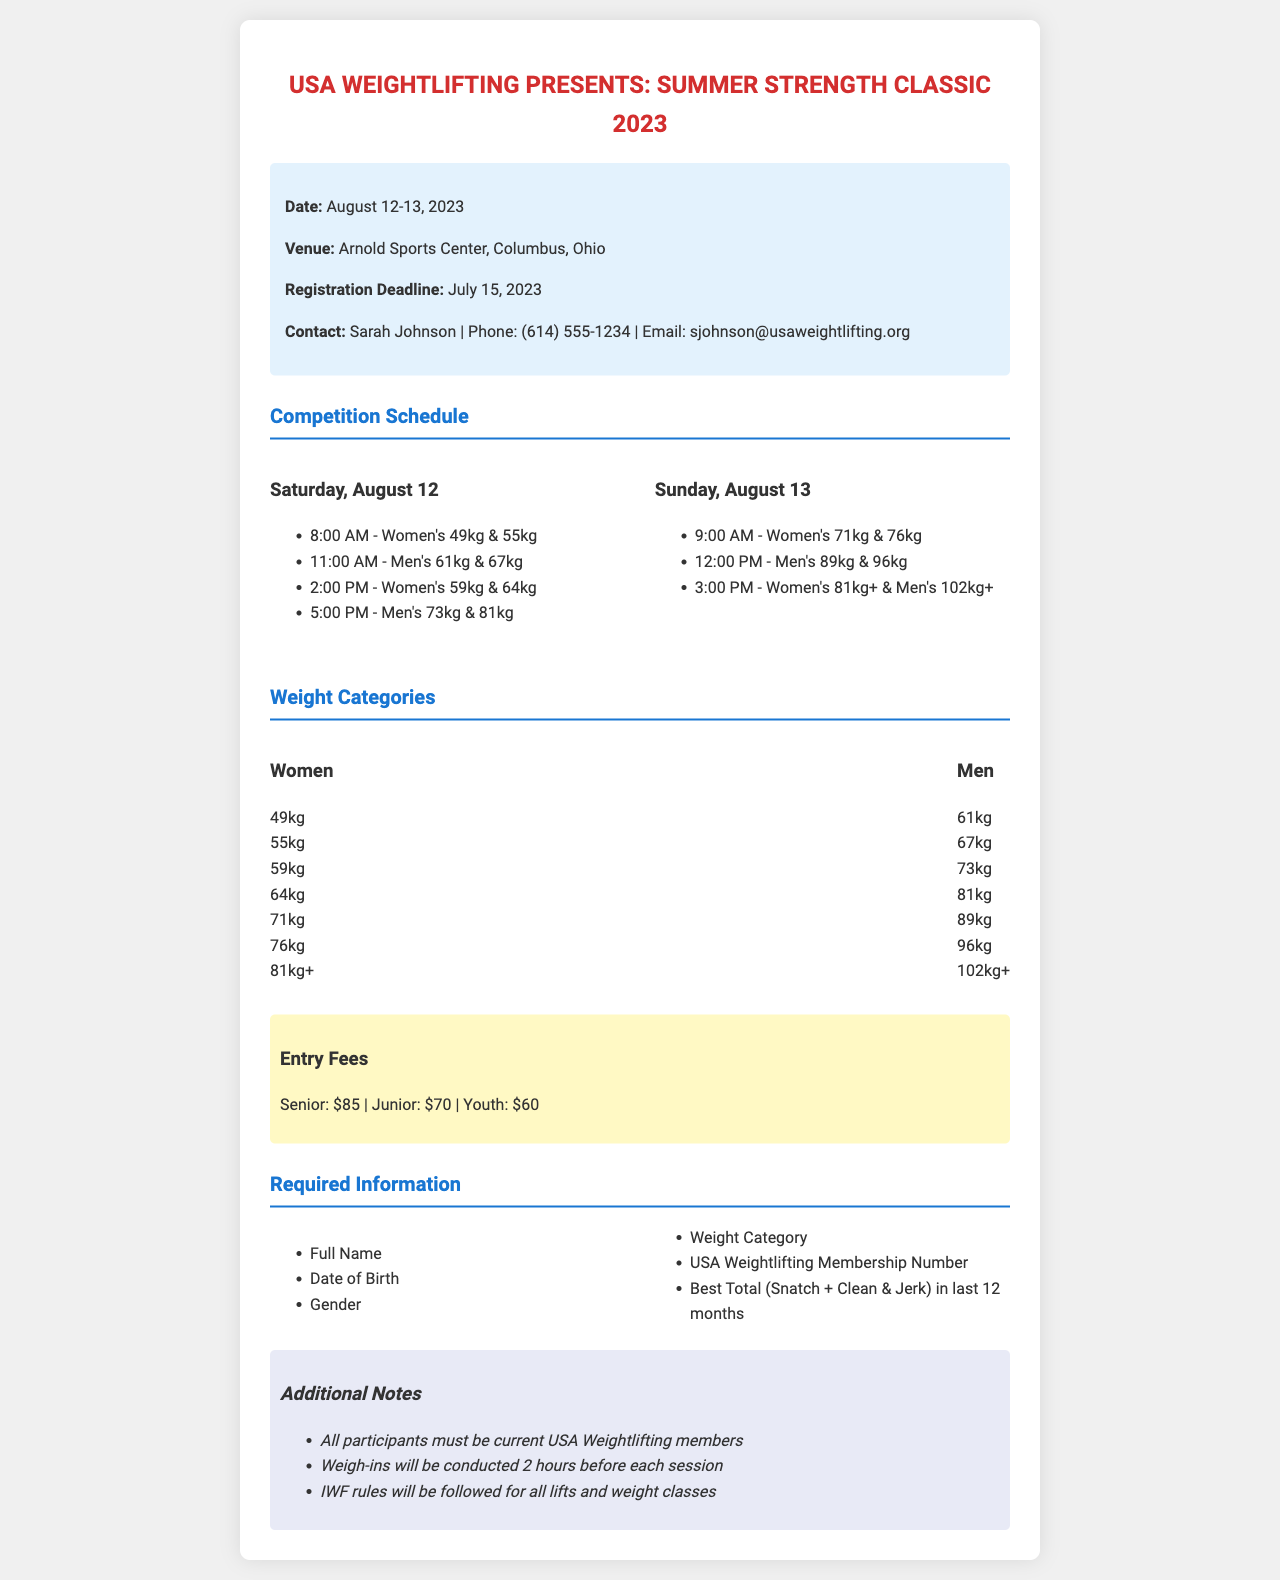what is the date of the competition? The date of the competition is mentioned at the beginning of the document.
Answer: August 12-13, 2023 where is the venue located? The venue details are provided in the info section of the document.
Answer: Arnold Sports Center, Columbus, Ohio what is the registration deadline? The registration deadline is explicitly stated in the information section.
Answer: July 15, 2023 how much is the entry fee for a Senior contestant? The entry fees are listed under the fees section of the document specifically.
Answer: $85 which weight category do women compete in at 8:00 AM on August 12? This information is found within the competition schedule for the first day.
Answer: Women's 49kg & 55kg how many sessions are scheduled for Women's categories on August 13? By reviewing the schedule, we can identify the number of sessions for Women's categories that day.
Answer: 2 sessions who is the contact person for the tournament? The contact information is provided within the introductory details of the document.
Answer: Sarah Johnson what must all participants be before competing? The additional notes section specifies a requirement for participation in the event.
Answer: current USA Weightlifting members what is the age range for the Junior entry fee? The age category for the Junior fee can be inferred from the context of weightlifting events.
Answer: Under 20 years old 